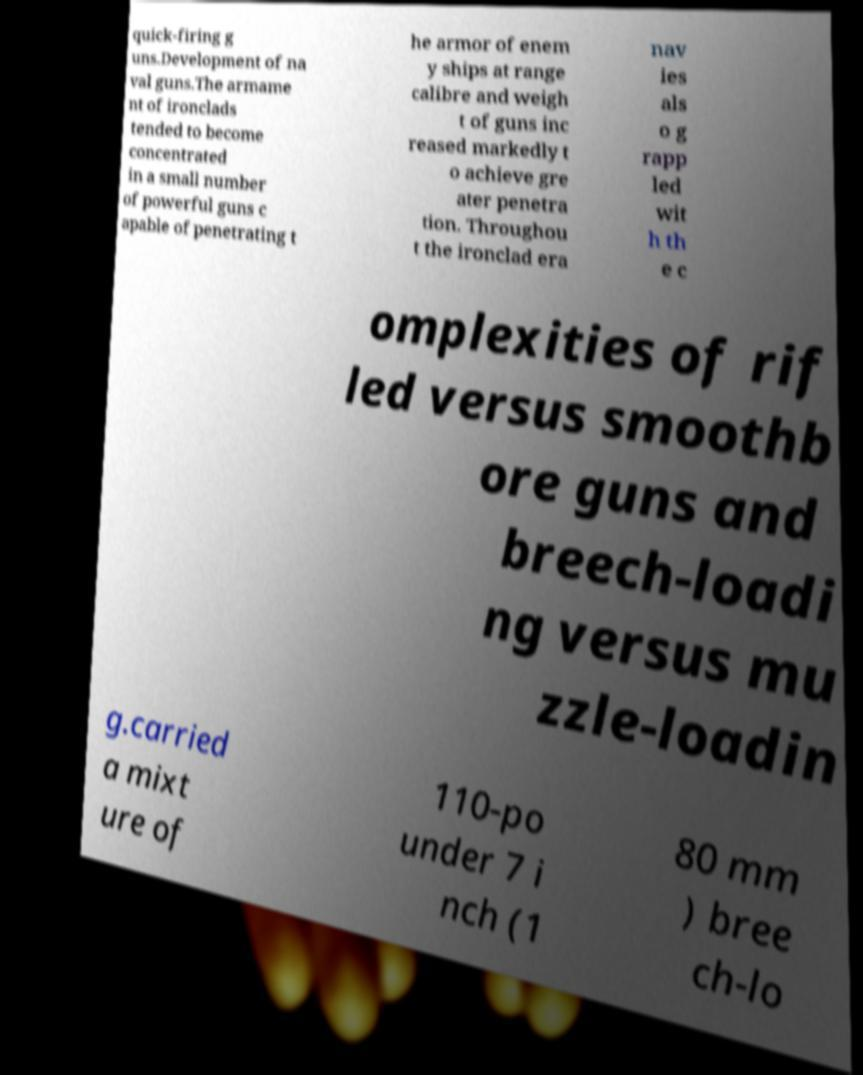There's text embedded in this image that I need extracted. Can you transcribe it verbatim? quick-firing g uns.Development of na val guns.The armame nt of ironclads tended to become concentrated in a small number of powerful guns c apable of penetrating t he armor of enem y ships at range calibre and weigh t of guns inc reased markedly t o achieve gre ater penetra tion. Throughou t the ironclad era nav ies als o g rapp led wit h th e c omplexities of rif led versus smoothb ore guns and breech-loadi ng versus mu zzle-loadin g.carried a mixt ure of 110-po under 7 i nch (1 80 mm ) bree ch-lo 